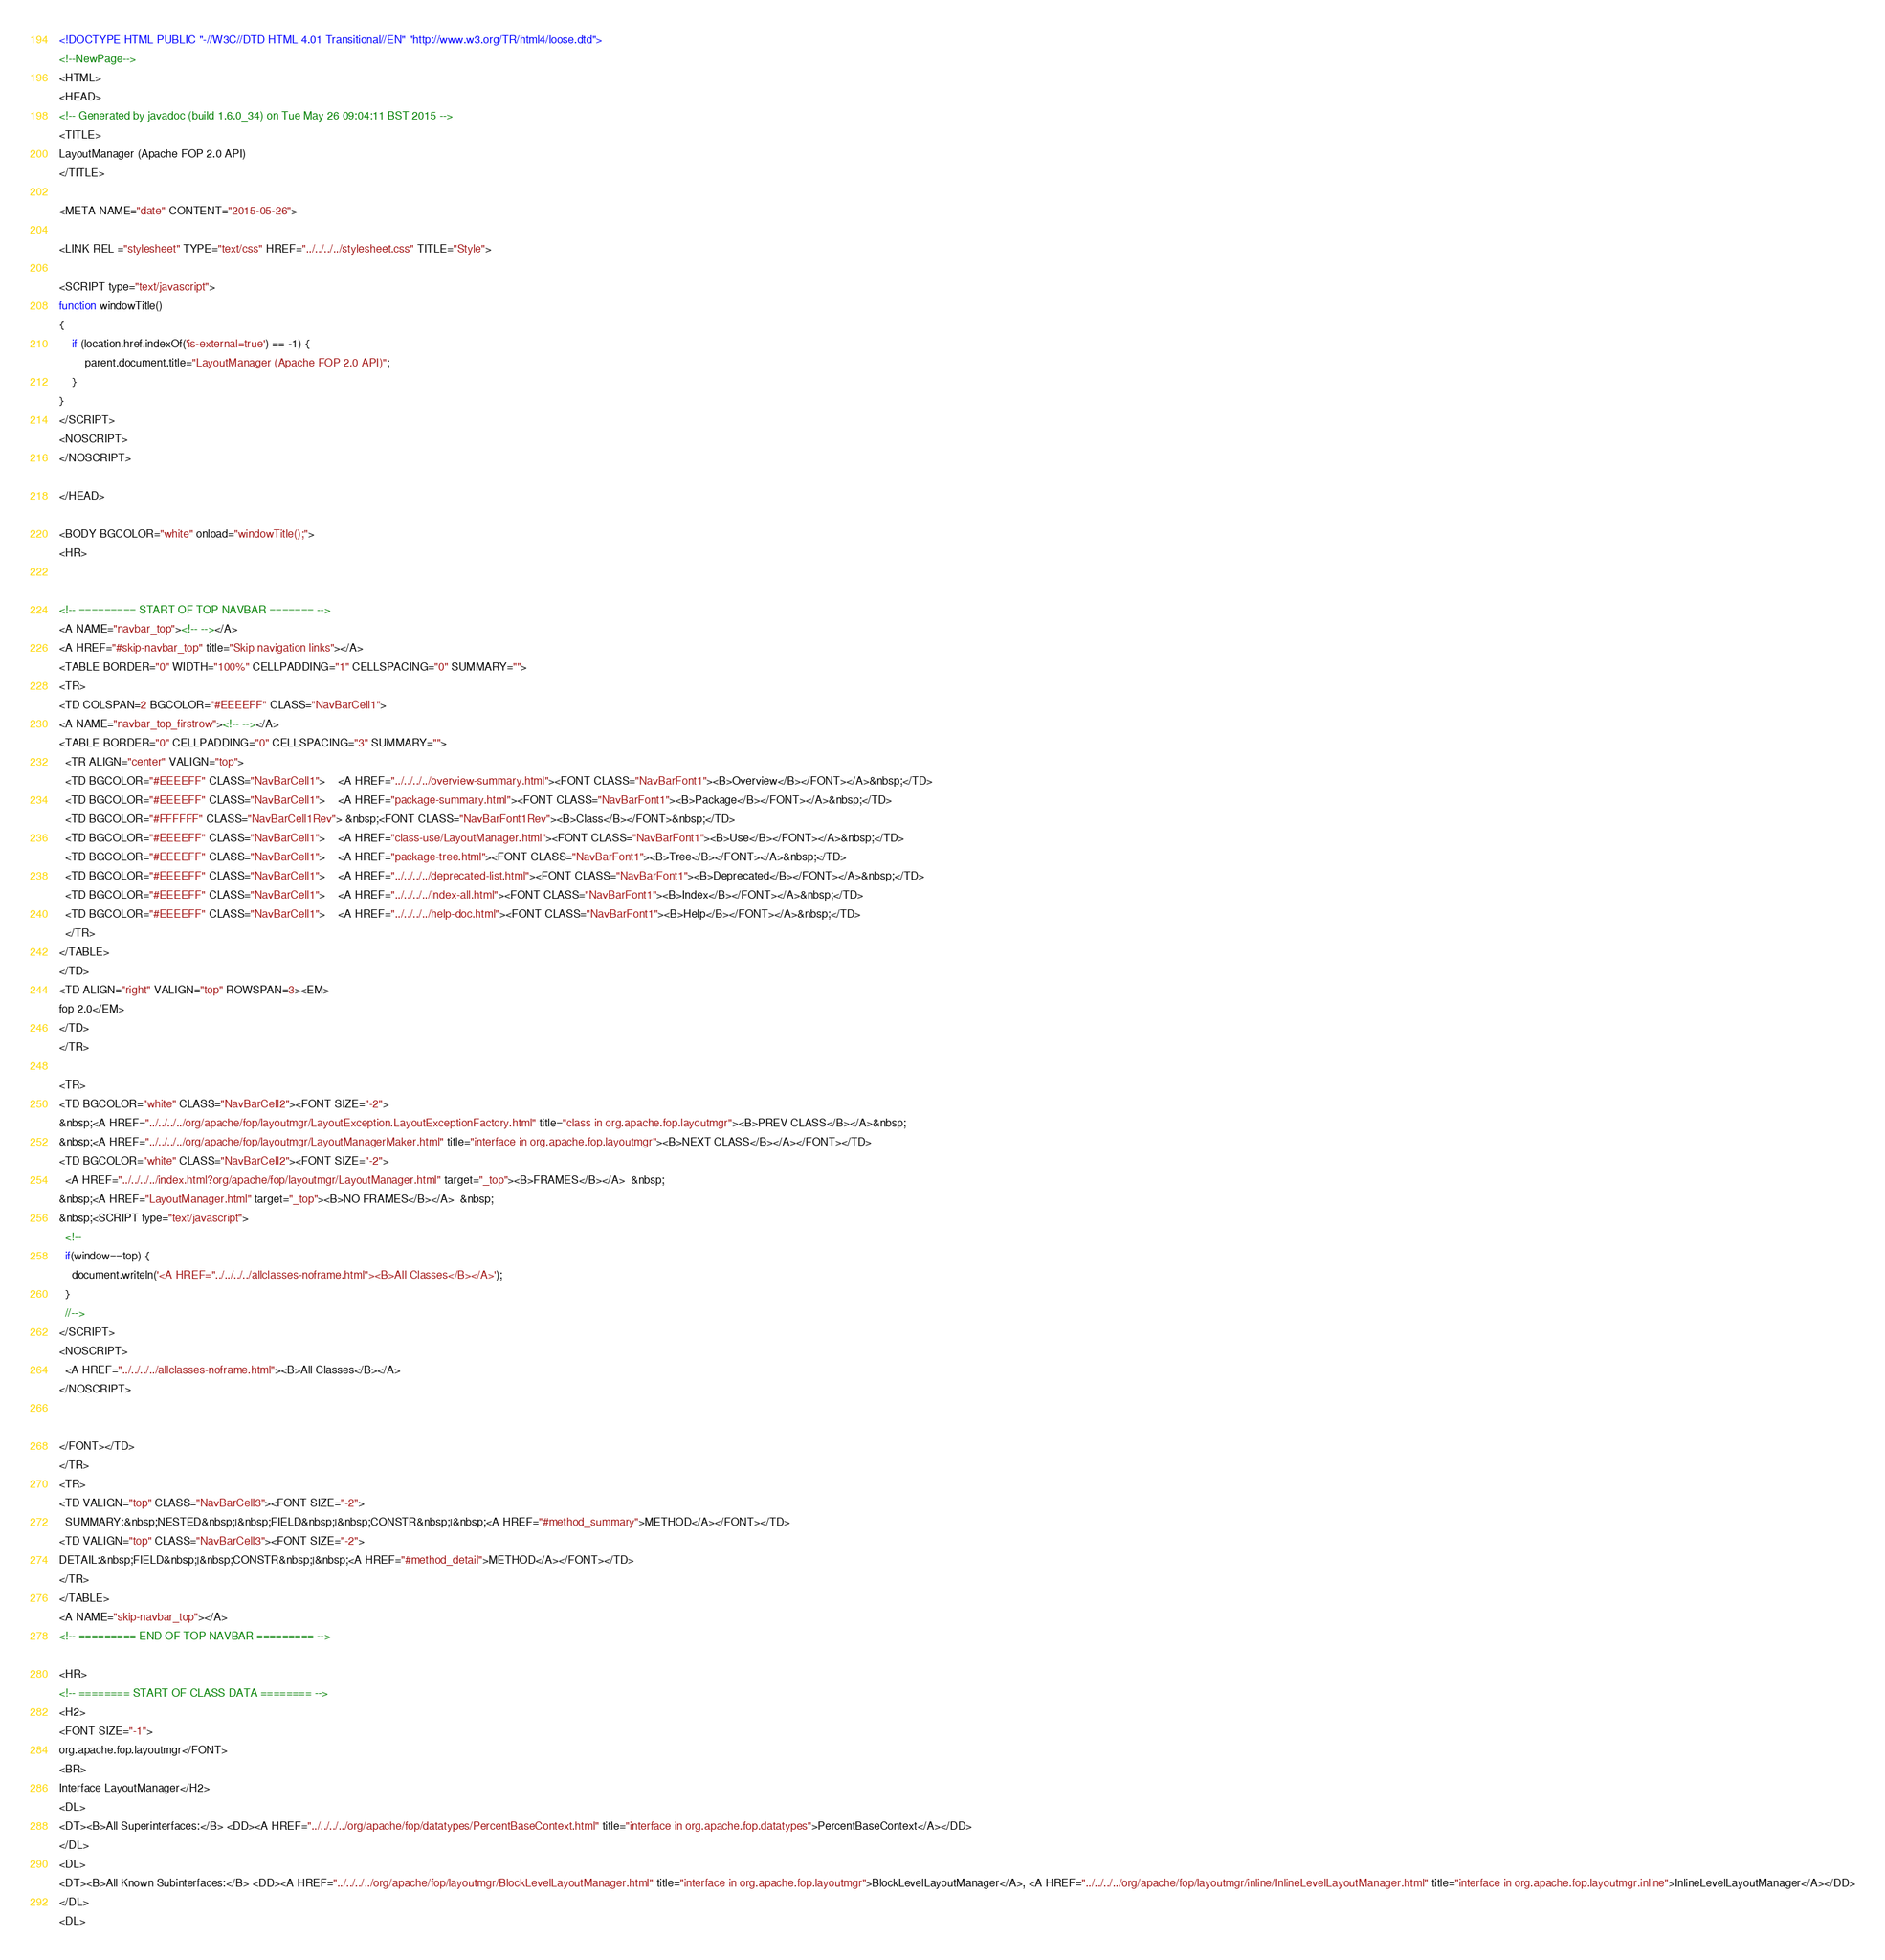Convert code to text. <code><loc_0><loc_0><loc_500><loc_500><_HTML_><!DOCTYPE HTML PUBLIC "-//W3C//DTD HTML 4.01 Transitional//EN" "http://www.w3.org/TR/html4/loose.dtd">
<!--NewPage-->
<HTML>
<HEAD>
<!-- Generated by javadoc (build 1.6.0_34) on Tue May 26 09:04:11 BST 2015 -->
<TITLE>
LayoutManager (Apache FOP 2.0 API)
</TITLE>

<META NAME="date" CONTENT="2015-05-26">

<LINK REL ="stylesheet" TYPE="text/css" HREF="../../../../stylesheet.css" TITLE="Style">

<SCRIPT type="text/javascript">
function windowTitle()
{
    if (location.href.indexOf('is-external=true') == -1) {
        parent.document.title="LayoutManager (Apache FOP 2.0 API)";
    }
}
</SCRIPT>
<NOSCRIPT>
</NOSCRIPT>

</HEAD>

<BODY BGCOLOR="white" onload="windowTitle();">
<HR>


<!-- ========= START OF TOP NAVBAR ======= -->
<A NAME="navbar_top"><!-- --></A>
<A HREF="#skip-navbar_top" title="Skip navigation links"></A>
<TABLE BORDER="0" WIDTH="100%" CELLPADDING="1" CELLSPACING="0" SUMMARY="">
<TR>
<TD COLSPAN=2 BGCOLOR="#EEEEFF" CLASS="NavBarCell1">
<A NAME="navbar_top_firstrow"><!-- --></A>
<TABLE BORDER="0" CELLPADDING="0" CELLSPACING="3" SUMMARY="">
  <TR ALIGN="center" VALIGN="top">
  <TD BGCOLOR="#EEEEFF" CLASS="NavBarCell1">    <A HREF="../../../../overview-summary.html"><FONT CLASS="NavBarFont1"><B>Overview</B></FONT></A>&nbsp;</TD>
  <TD BGCOLOR="#EEEEFF" CLASS="NavBarCell1">    <A HREF="package-summary.html"><FONT CLASS="NavBarFont1"><B>Package</B></FONT></A>&nbsp;</TD>
  <TD BGCOLOR="#FFFFFF" CLASS="NavBarCell1Rev"> &nbsp;<FONT CLASS="NavBarFont1Rev"><B>Class</B></FONT>&nbsp;</TD>
  <TD BGCOLOR="#EEEEFF" CLASS="NavBarCell1">    <A HREF="class-use/LayoutManager.html"><FONT CLASS="NavBarFont1"><B>Use</B></FONT></A>&nbsp;</TD>
  <TD BGCOLOR="#EEEEFF" CLASS="NavBarCell1">    <A HREF="package-tree.html"><FONT CLASS="NavBarFont1"><B>Tree</B></FONT></A>&nbsp;</TD>
  <TD BGCOLOR="#EEEEFF" CLASS="NavBarCell1">    <A HREF="../../../../deprecated-list.html"><FONT CLASS="NavBarFont1"><B>Deprecated</B></FONT></A>&nbsp;</TD>
  <TD BGCOLOR="#EEEEFF" CLASS="NavBarCell1">    <A HREF="../../../../index-all.html"><FONT CLASS="NavBarFont1"><B>Index</B></FONT></A>&nbsp;</TD>
  <TD BGCOLOR="#EEEEFF" CLASS="NavBarCell1">    <A HREF="../../../../help-doc.html"><FONT CLASS="NavBarFont1"><B>Help</B></FONT></A>&nbsp;</TD>
  </TR>
</TABLE>
</TD>
<TD ALIGN="right" VALIGN="top" ROWSPAN=3><EM>
fop 2.0</EM>
</TD>
</TR>

<TR>
<TD BGCOLOR="white" CLASS="NavBarCell2"><FONT SIZE="-2">
&nbsp;<A HREF="../../../../org/apache/fop/layoutmgr/LayoutException.LayoutExceptionFactory.html" title="class in org.apache.fop.layoutmgr"><B>PREV CLASS</B></A>&nbsp;
&nbsp;<A HREF="../../../../org/apache/fop/layoutmgr/LayoutManagerMaker.html" title="interface in org.apache.fop.layoutmgr"><B>NEXT CLASS</B></A></FONT></TD>
<TD BGCOLOR="white" CLASS="NavBarCell2"><FONT SIZE="-2">
  <A HREF="../../../../index.html?org/apache/fop/layoutmgr/LayoutManager.html" target="_top"><B>FRAMES</B></A>  &nbsp;
&nbsp;<A HREF="LayoutManager.html" target="_top"><B>NO FRAMES</B></A>  &nbsp;
&nbsp;<SCRIPT type="text/javascript">
  <!--
  if(window==top) {
    document.writeln('<A HREF="../../../../allclasses-noframe.html"><B>All Classes</B></A>');
  }
  //-->
</SCRIPT>
<NOSCRIPT>
  <A HREF="../../../../allclasses-noframe.html"><B>All Classes</B></A>
</NOSCRIPT>


</FONT></TD>
</TR>
<TR>
<TD VALIGN="top" CLASS="NavBarCell3"><FONT SIZE="-2">
  SUMMARY:&nbsp;NESTED&nbsp;|&nbsp;FIELD&nbsp;|&nbsp;CONSTR&nbsp;|&nbsp;<A HREF="#method_summary">METHOD</A></FONT></TD>
<TD VALIGN="top" CLASS="NavBarCell3"><FONT SIZE="-2">
DETAIL:&nbsp;FIELD&nbsp;|&nbsp;CONSTR&nbsp;|&nbsp;<A HREF="#method_detail">METHOD</A></FONT></TD>
</TR>
</TABLE>
<A NAME="skip-navbar_top"></A>
<!-- ========= END OF TOP NAVBAR ========= -->

<HR>
<!-- ======== START OF CLASS DATA ======== -->
<H2>
<FONT SIZE="-1">
org.apache.fop.layoutmgr</FONT>
<BR>
Interface LayoutManager</H2>
<DL>
<DT><B>All Superinterfaces:</B> <DD><A HREF="../../../../org/apache/fop/datatypes/PercentBaseContext.html" title="interface in org.apache.fop.datatypes">PercentBaseContext</A></DD>
</DL>
<DL>
<DT><B>All Known Subinterfaces:</B> <DD><A HREF="../../../../org/apache/fop/layoutmgr/BlockLevelLayoutManager.html" title="interface in org.apache.fop.layoutmgr">BlockLevelLayoutManager</A>, <A HREF="../../../../org/apache/fop/layoutmgr/inline/InlineLevelLayoutManager.html" title="interface in org.apache.fop.layoutmgr.inline">InlineLevelLayoutManager</A></DD>
</DL>
<DL></code> 